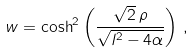Convert formula to latex. <formula><loc_0><loc_0><loc_500><loc_500>w = \cosh ^ { 2 } \left ( \frac { \sqrt { 2 } \, \rho } { \sqrt { l ^ { 2 } - 4 \alpha } } \right ) \, ,</formula> 